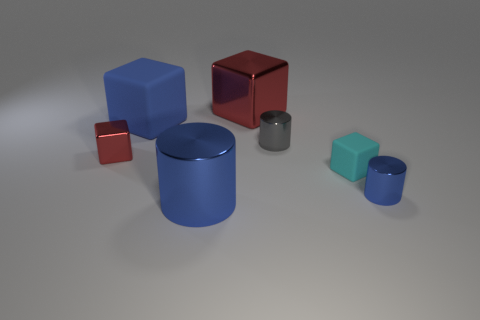Does the large thing that is left of the big blue cylinder have the same color as the cylinder that is behind the small blue metallic cylinder?
Your answer should be compact. No. Are there fewer cyan matte objects than small yellow rubber cubes?
Provide a succinct answer. No. There is a large blue object in front of the cylinder that is behind the small metal block; what shape is it?
Ensure brevity in your answer.  Cylinder. What shape is the blue metallic object that is right of the big metal object behind the small thing in front of the small cyan object?
Ensure brevity in your answer.  Cylinder. What number of things are tiny blocks that are right of the blue matte cube or tiny metallic cylinders behind the small red shiny thing?
Your answer should be very brief. 2. There is a blue matte block; is it the same size as the cylinder behind the small red metallic object?
Offer a very short reply. No. Does the blue object to the right of the cyan matte object have the same material as the block that is right of the big red metal object?
Your answer should be very brief. No. Are there an equal number of small blue metallic cylinders that are left of the cyan rubber thing and small blue cylinders that are behind the blue matte thing?
Offer a very short reply. Yes. How many metal cylinders have the same color as the big rubber block?
Your response must be concise. 2. There is a large cube that is the same color as the big metal cylinder; what is its material?
Your answer should be very brief. Rubber. 